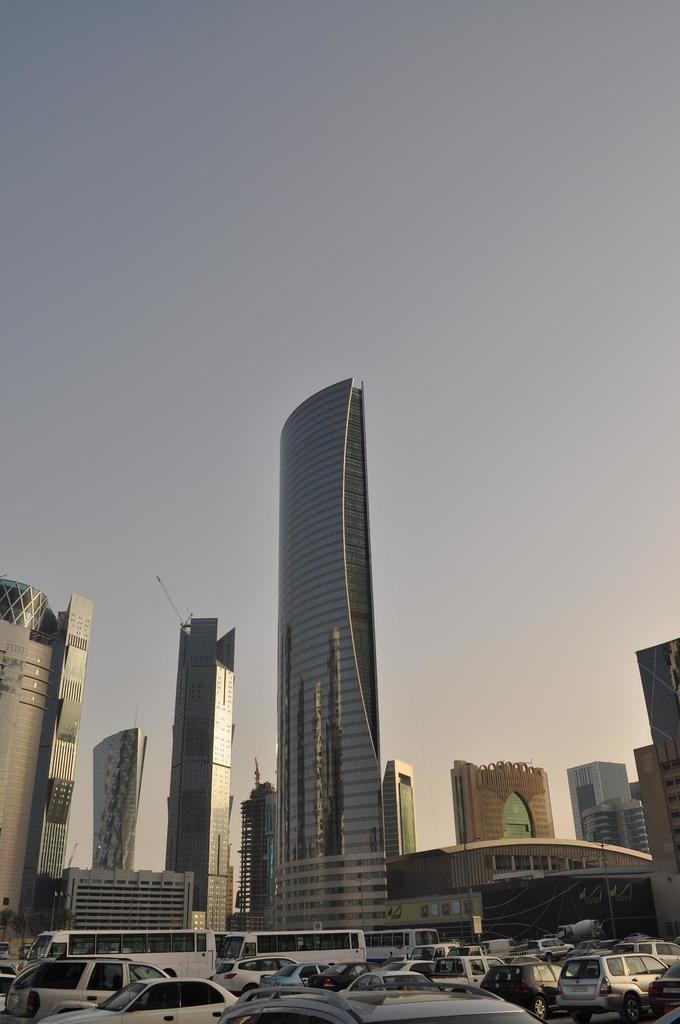What type of structures can be seen in the image? There are buildings in the image. What else can be seen on the ground in the image? Vehicles are visible on the road in the image. What is visible in the background of the image? The sky is visible in the background of the image. What type of vegetable is being used as a rhythm instrument in the image? There is no vegetable or rhythm instrument present in the image. 